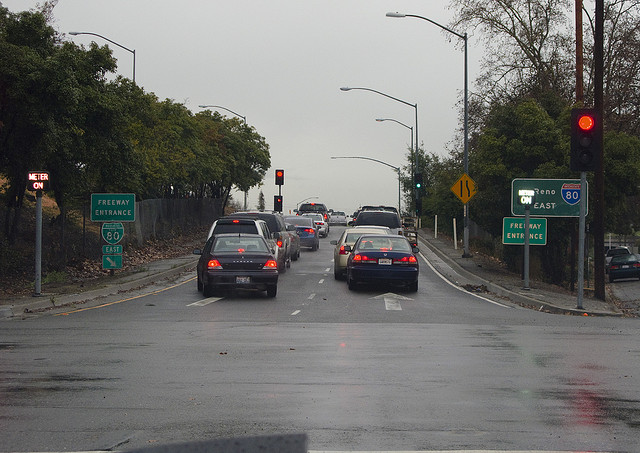Read all the text in this image. ENTRANCE EAST EAST 80 80 